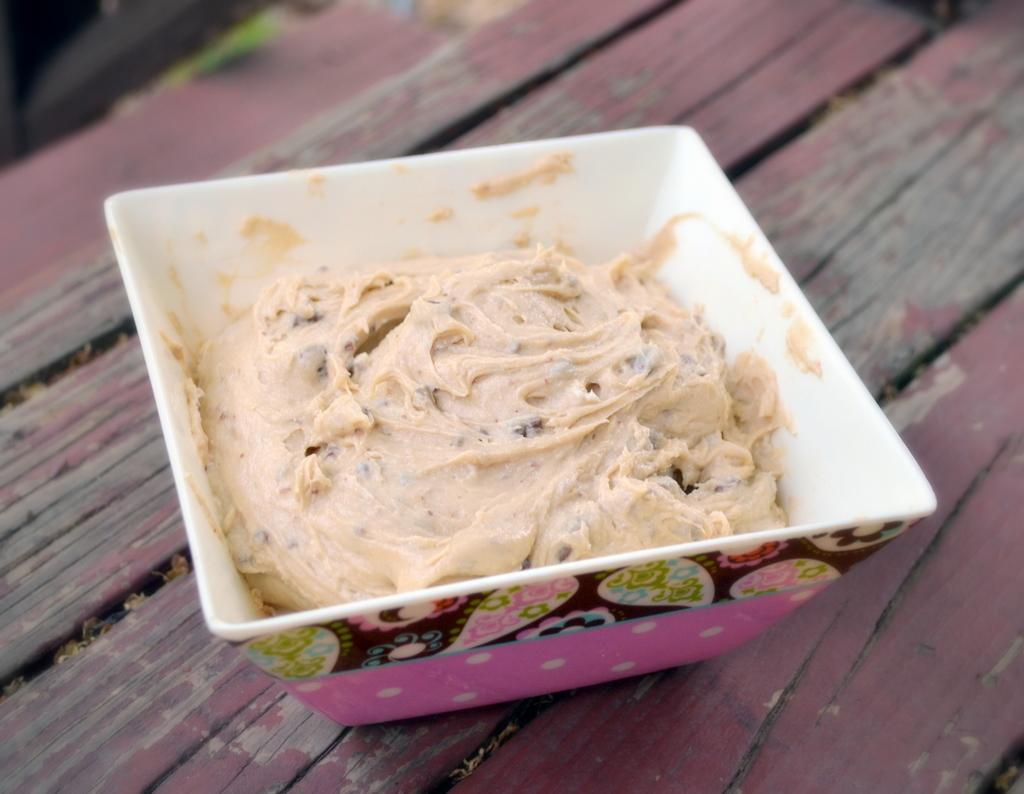What is the main subject of the image? The main subject of the image is an ice cream. How is the ice cream contained in the image? The ice cream is in a bowl. Where is the bowl with the ice cream located? The bowl is placed on a table. What type of brush is being used to paint the ice cream in the image? There is no brush or painting activity present in the image; it simply shows a bowl of ice cream on a table. 